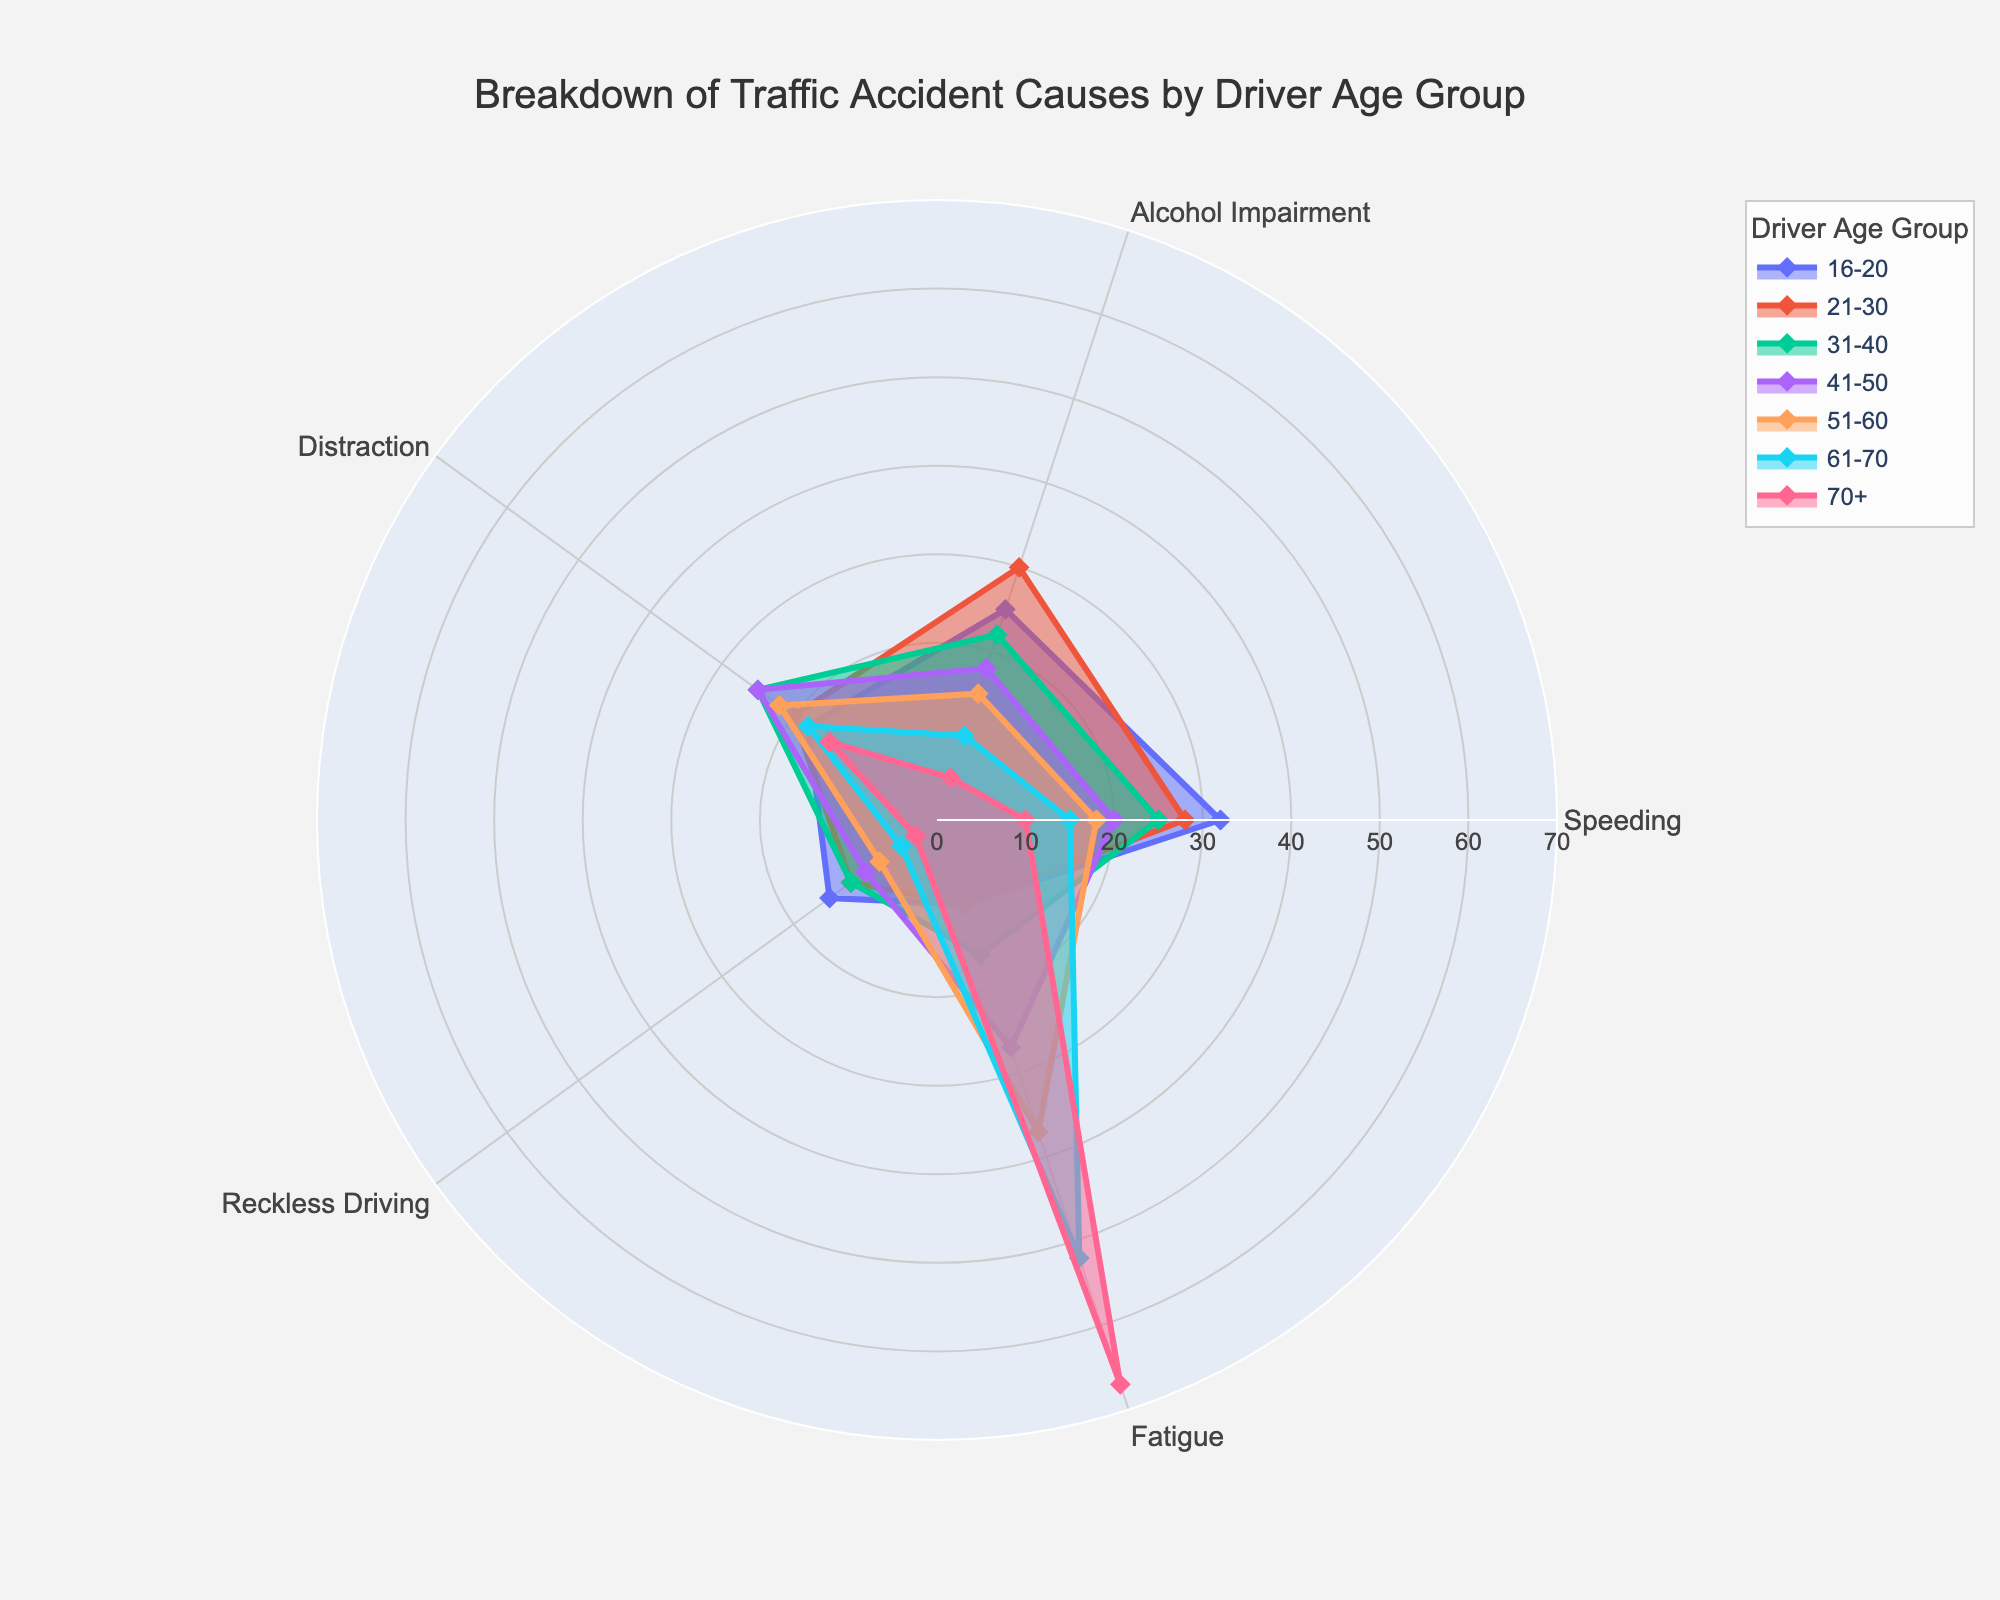Which age group has the highest percentage of accidents due to speeding? The radar chart shows different lines representing each age group's causes of accidents. The line that extends the farthest toward the speeding axis represents the highest percentage. The "16-20" age group has the longest extension.
Answer: 16-20 Which cause of accidents is the most significant for the 70+ age group? The radar chart portrays the extent of each cause's influence on an age group by the distance from the center to the edge. For the 70+ age group line, "Fatigue" extends the farthest.
Answer: Fatigue How does the percentage of accidents caused by alcohol impairment compare between the "21-30" and "61-70" age groups? The radar chart shows percentages for each age group side by side. The "21-30" age group has a longer extension for alcohol impairment than the "61-70" age group.
Answer: Higher for 21-30 What is the most common cause of accidents for the "31-40" age group? Look at the "31-40" age group's line and identify which cause shows the maximum extension from the center. "Distraction" and "Speeding" have the joint furthest extension.
Answer: Distraction and Speeding Which age group shows the lowest percentage of accidents due to reckless driving? Examine the extent to which each age group's line extends toward the reckless driving axis. The "70+" age group's line is the shortest.
Answer: 70+ Which age group has the most balanced percentages across all causes? Look for the age group whose line appears most equidistant across all the different causes without steep variations. The "41-50" age group has relatively balanced extensions across causes.
Answer: 41-50 What is the combined percentage of accidents due to fatigue in the "51-60" and "61-70" age groups? Find the percentages for fatigue for "51-60" and "61-70" age groups and add them: 37% + 52%.
Answer: 89% Compare the impact of distraction between the "16-20" and "41-50" age groups. Which one is higher and by how much? Identify the percentages of distraction for both "16-20" and "41-50" age groups. Subtract the smaller percentage (18%) from the larger one (25%).
Answer: Higher for 41-50 by 7% What is the average percentage of accidents caused by speeding, calculated across all age groups? Sum the percentages of accidents caused by speeding for each age group: 32 + 28 + 25 + 20 + 18 + 15 + 10 = 148. Divide by the total number of age groups (7).
Answer: 21.14% What cause appears least significant across all age groups? Look at each cause axis and see which one consistently has smaller extensions from the center across all age groups. "Reckless Driving" typically shows the smallest extensions.
Answer: Reckless Driving 